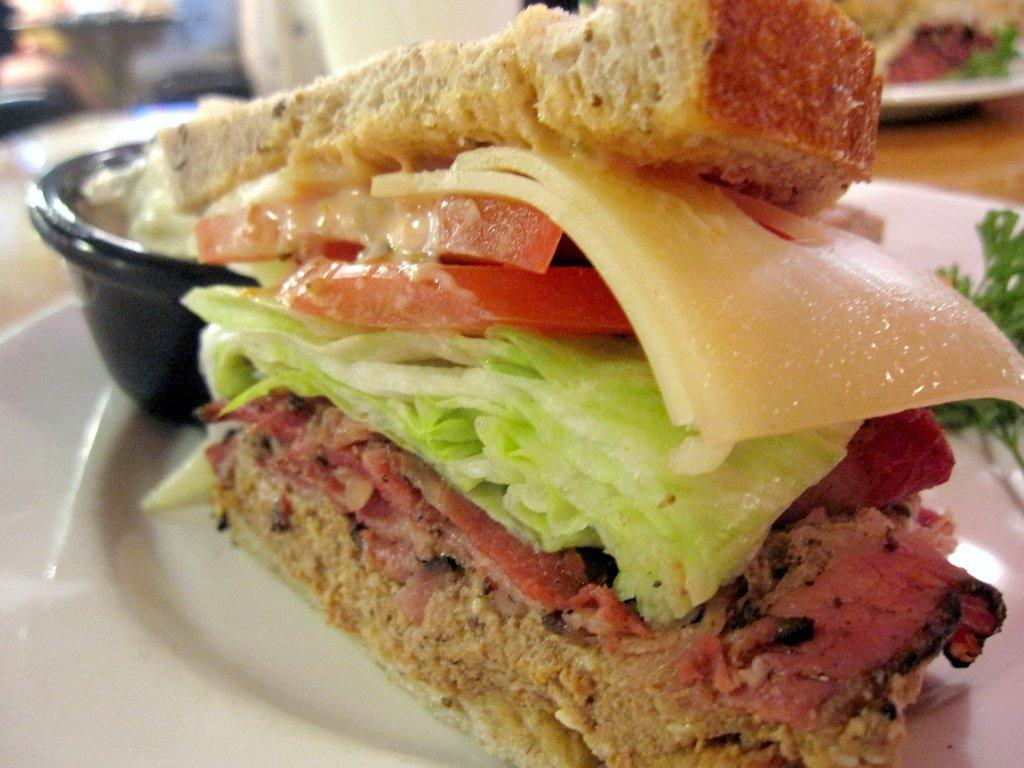What type of food is visible in the image? There is a sandwich in the image. What else is present on the plate in the image? There is a bowl in the image. Where are the sandwich and the bowl located? Both the sandwich and the bowl are on a plate in the image. Can you describe the background of the image? The background of the image is blurred. What type of nut is visible in the image? There is no nut present in the image. What type of fan is visible in the image? There is no fan present in the image. 